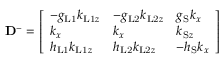<formula> <loc_0><loc_0><loc_500><loc_500>D ^ { - } = \left [ \begin{array} { l l l } { - g _ { L 1 } k _ { L 1 z } } & { - g _ { L 2 } k _ { L 2 z } } & { g _ { S } k _ { x } } \\ { k _ { x } } & { k _ { x } } & { k _ { S z } } \\ { h _ { L 1 } k _ { L 1 z } } & { h _ { L 2 } k _ { L 2 z } } & { - h _ { S } k _ { x } } \end{array} \right ]</formula> 